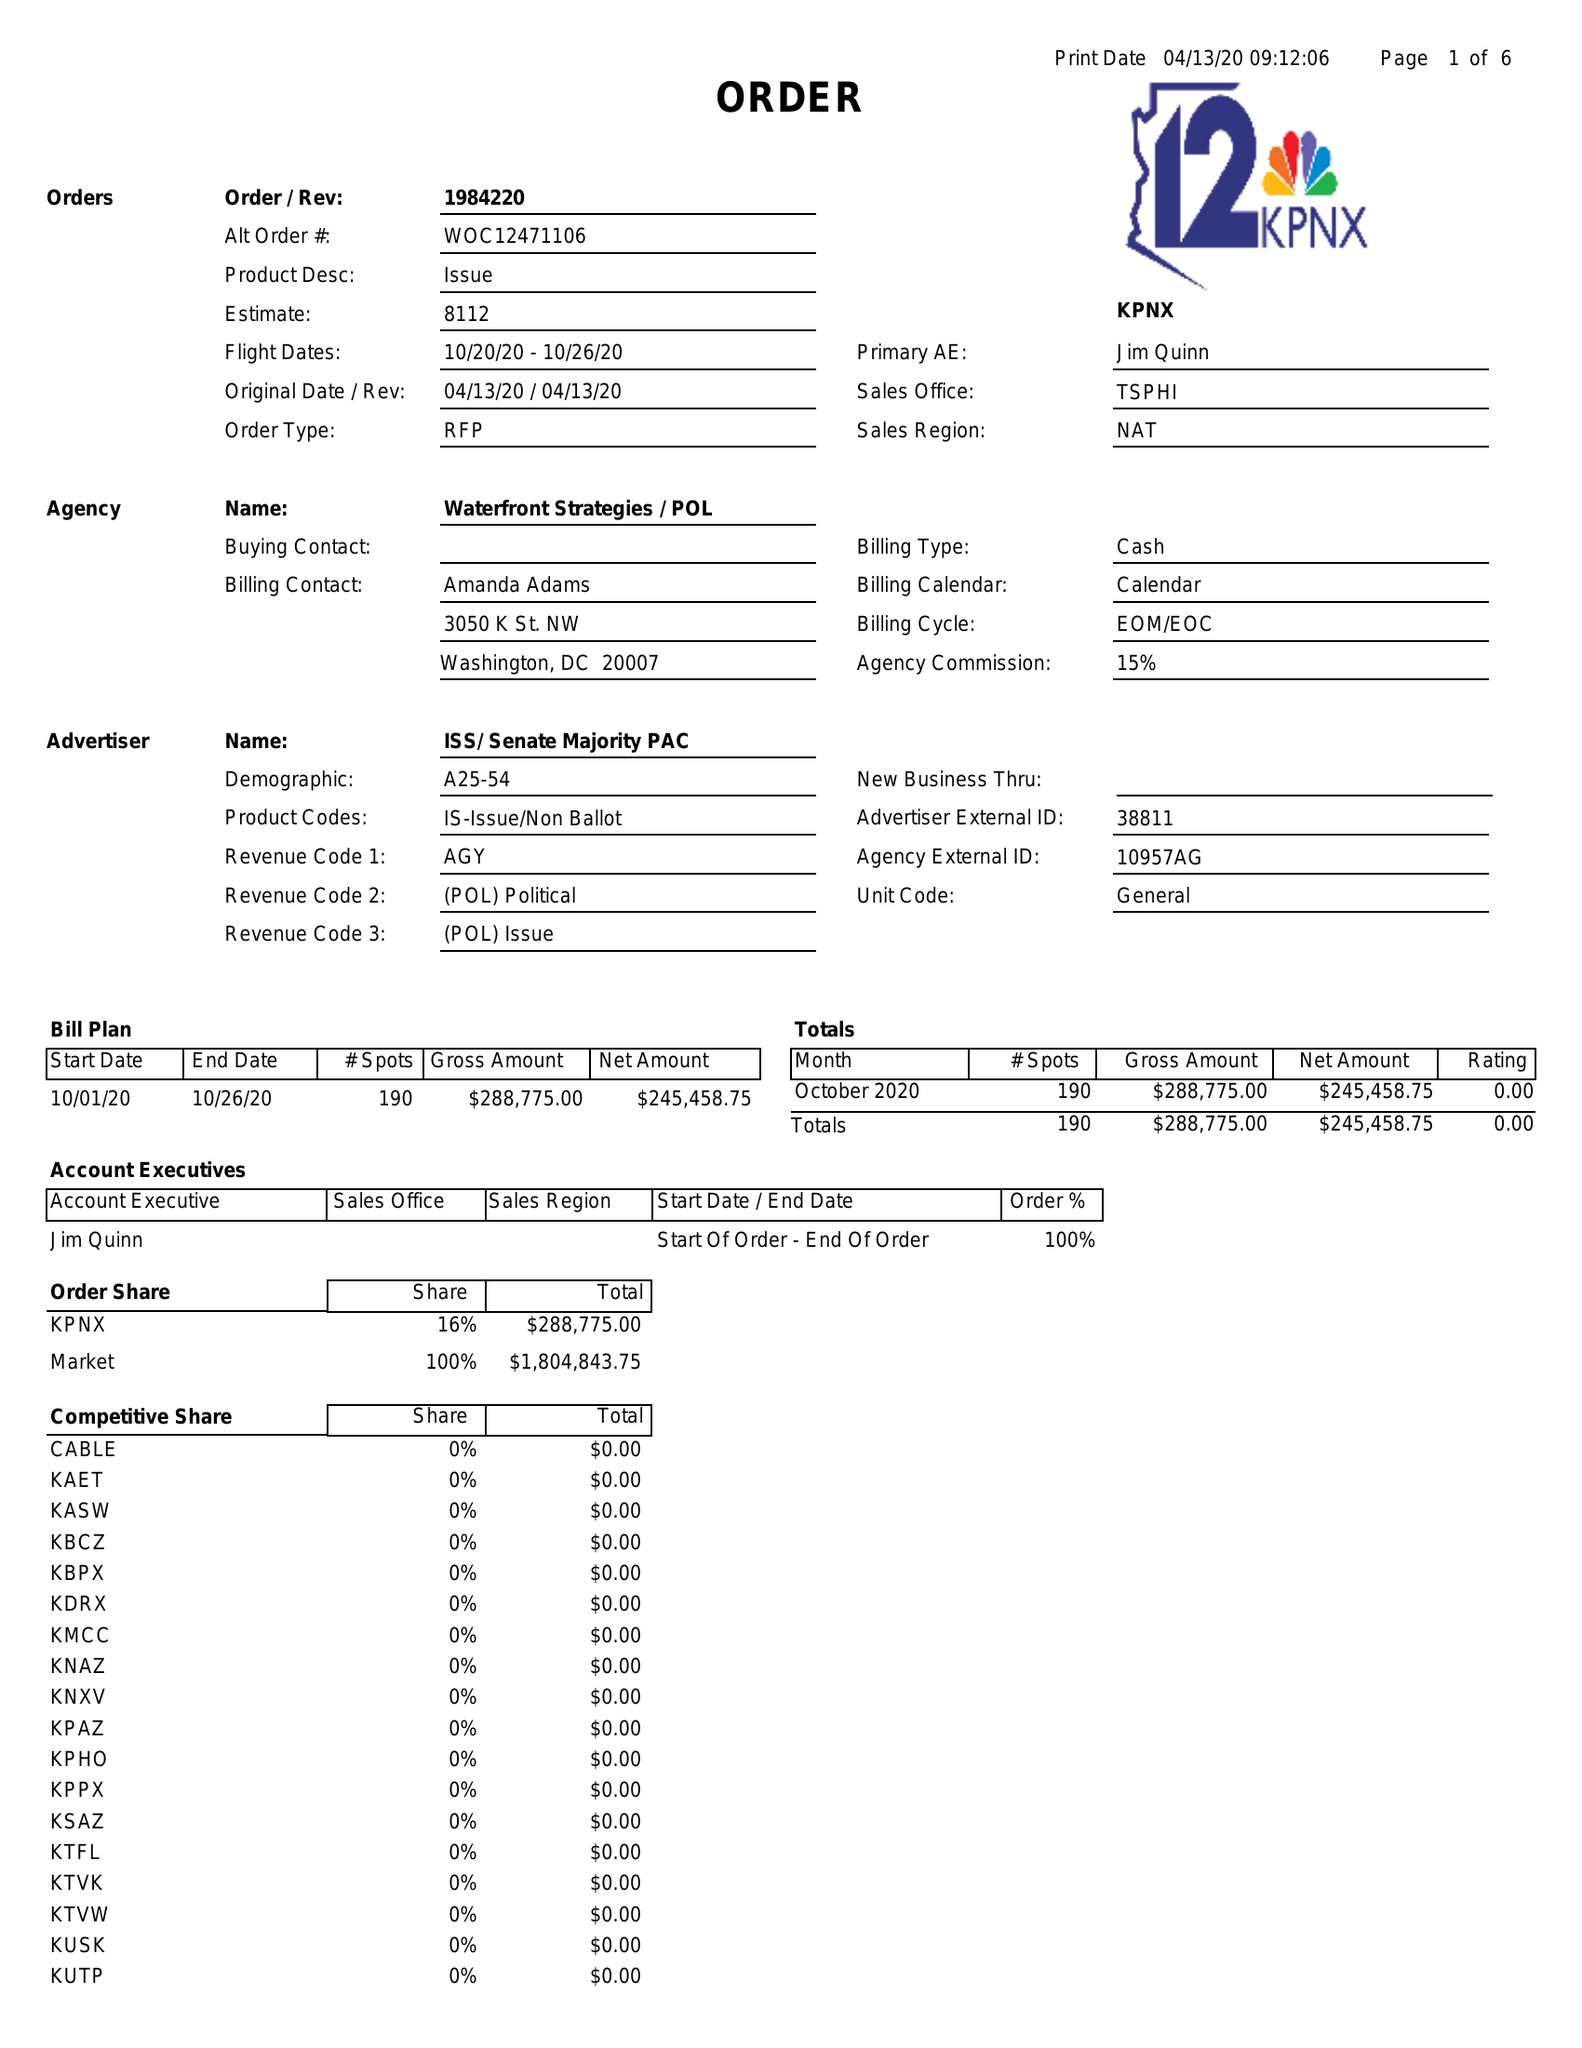What is the value for the flight_to?
Answer the question using a single word or phrase. 10/26/20 